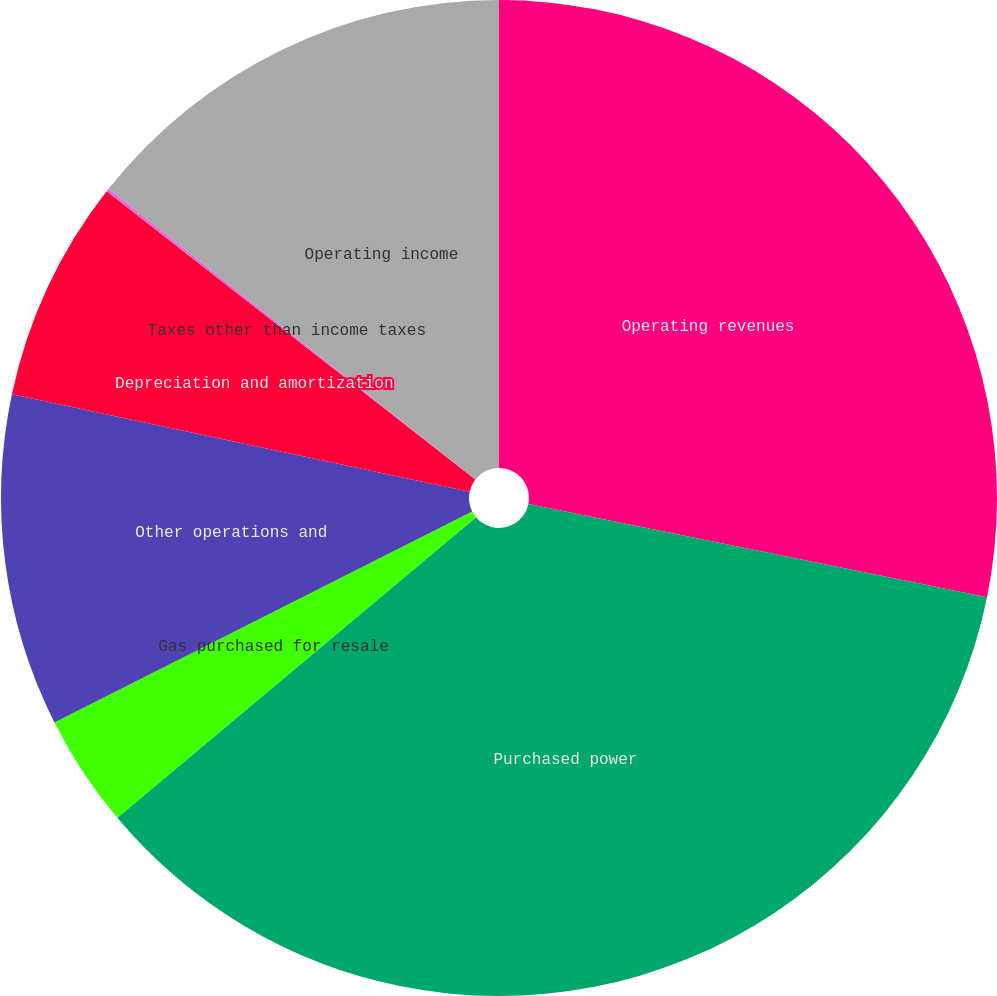<chart> <loc_0><loc_0><loc_500><loc_500><pie_chart><fcel>Operating revenues<fcel>Purchased power<fcel>Gas purchased for resale<fcel>Other operations and<fcel>Depreciation and amortization<fcel>Taxes other than income taxes<fcel>Operating income<nl><fcel>28.19%<fcel>35.71%<fcel>3.66%<fcel>10.78%<fcel>7.22%<fcel>0.1%<fcel>14.34%<nl></chart> 